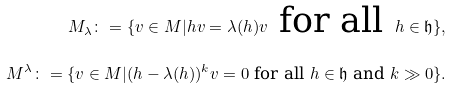<formula> <loc_0><loc_0><loc_500><loc_500>M _ { \lambda } \colon = \{ v \in M | h v = \lambda ( h ) v \text { for all } h \in \mathfrak { h } \} , \\ M ^ { \lambda } \colon = \{ v \in M | ( h - \lambda ( h ) ) ^ { k } v = 0 \text { for all } h \in \mathfrak { h } \text { and } k \gg 0 \} .</formula> 